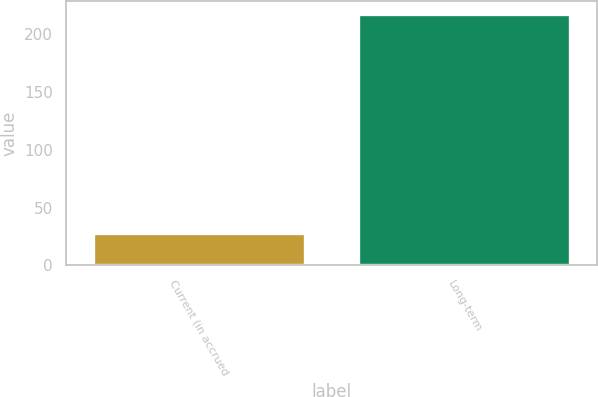Convert chart. <chart><loc_0><loc_0><loc_500><loc_500><bar_chart><fcel>Current (in accrued<fcel>Long-term<nl><fcel>28<fcel>218<nl></chart> 